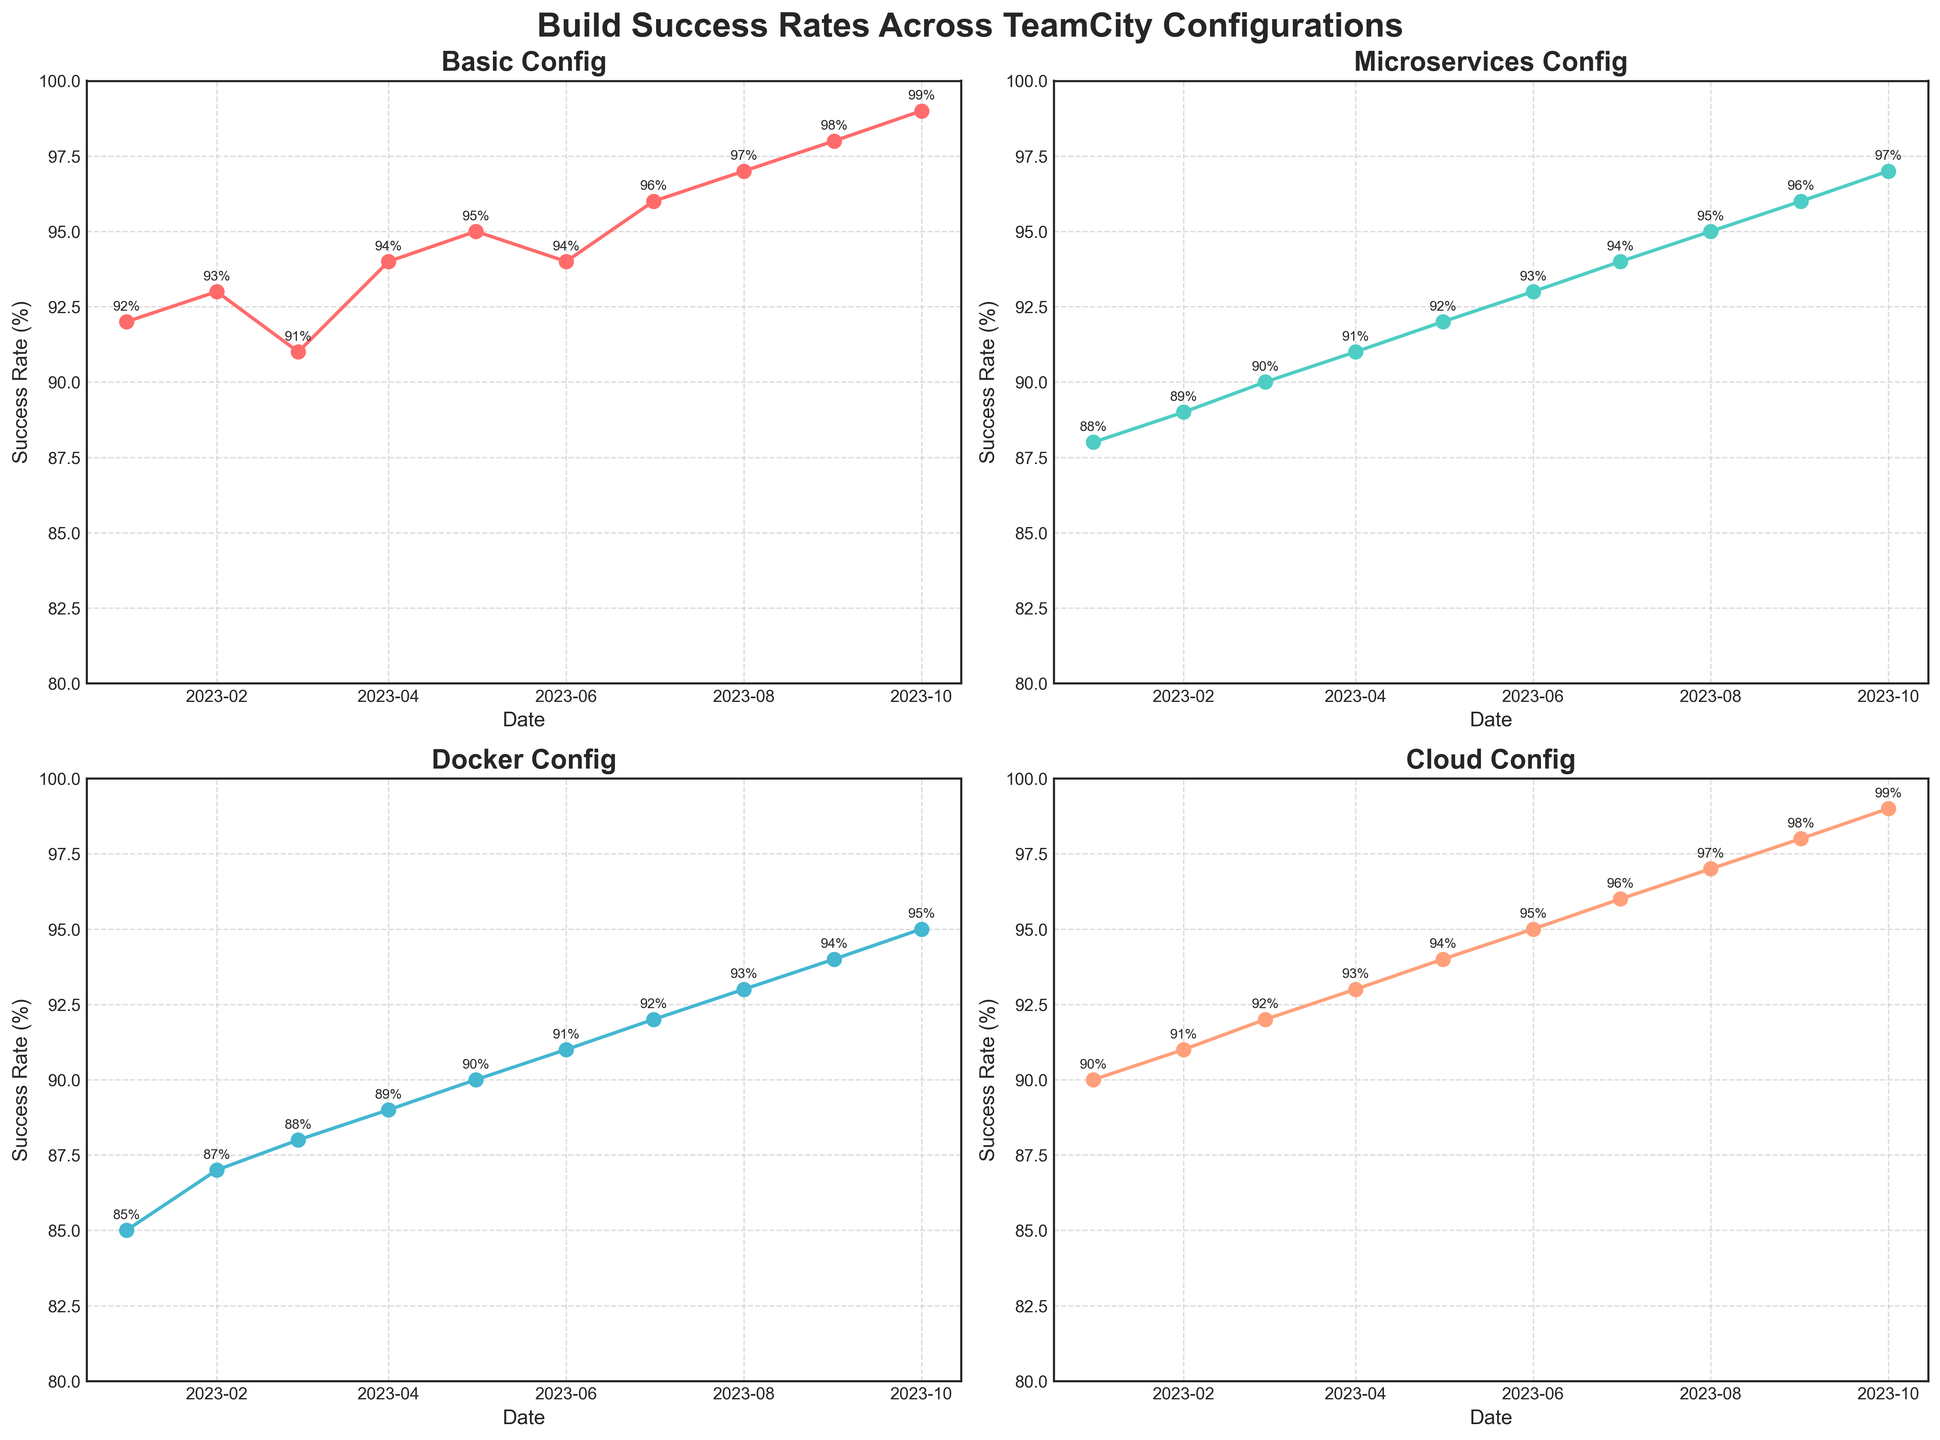what is the title of the figure? The title is shown at the top center of the figure. It reads "Build Success Rates Across TeamCity Configurations".
Answer: Build Success Rates Across TeamCity Configurations Which configuration has the highest success rate in October 2023? By looking at the data points for October 2023 across the four subplots, the Cloud Config shows the highest success rate at 99%.
Answer: Cloud Config How does the success rate of Docker Config change from January to October 2023? Identify the data points for Docker Config in January 2023 (85%) and October 2023 (95%). Calculate the change by subtracting January's value from October's value: 95% - 85%.
Answer: It increased by 10% What is the average success rate for Basic Config over the entire period? Sum all success rates for Basic Config from January 2023 to October 2023 and divide by the number of data points. The calculation is: (92 + 93 + 91 + 94 + 95 + 94 + 96 + 97 + 98 + 99) / 10.
Answer: 94.9% Did any configuration maintain a consistent upward trend throughout 2023? By analyzing each subplot, note if any configurations' success rates never decrease from one month to the next. Both the Basic Config and Cloud Config show consistent upward trends.
Answer: Yes, Basic Config and Cloud Config Which month had the most significant increase in success rate for Microservices Config? Compare the month-to-month increase for Microservices Config. The largest increase occurs between June (93%) and July (94%), which is 1%.
Answer: June to July How many times did the Cloud Config success rate increase by more than 1% from one month to the next? Examine the success rates for Cloud Config and count the instances where the month-to-month increase is greater than 1%. This happens between March-April and May-June.
Answer: 2 times What are the minimum success rates observed for each configuration? Identify the lowest data point for each configuration from the subplots. Basic Config: 91%, Microservices Config: 88%, Docker Config: 85%, Cloud Config: 90%.
Answer: Basic Config: 91%, Microservices Config: 88%, Docker Config: 85%, Cloud Config: 90% Which configuration showed the least overall improvement from January to October 2023? Calculate the difference between October and January success rates for each configuration. Docker Config: 95-85 = 10%. All other configurations have improvements greater than 10%.
Answer: Docker Config What is the median success rate for the Cloud Config? Arrange the success rates of Cloud Config in ascending order and find the middle value. Ordered values are 90, 91, 92, 93, 94, 95, 96, 97, 98, 99. The middle values are 94 and 95; the median is the average of these two: (94+95)/2.
Answer: 94.5% 